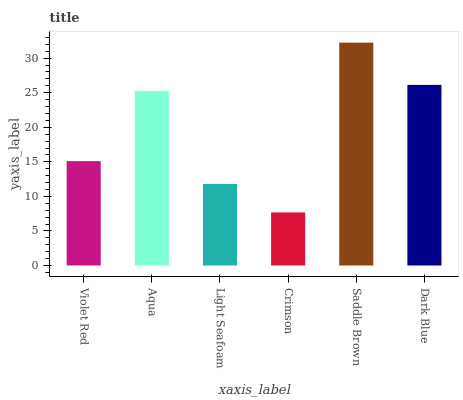Is Crimson the minimum?
Answer yes or no. Yes. Is Saddle Brown the maximum?
Answer yes or no. Yes. Is Aqua the minimum?
Answer yes or no. No. Is Aqua the maximum?
Answer yes or no. No. Is Aqua greater than Violet Red?
Answer yes or no. Yes. Is Violet Red less than Aqua?
Answer yes or no. Yes. Is Violet Red greater than Aqua?
Answer yes or no. No. Is Aqua less than Violet Red?
Answer yes or no. No. Is Aqua the high median?
Answer yes or no. Yes. Is Violet Red the low median?
Answer yes or no. Yes. Is Crimson the high median?
Answer yes or no. No. Is Saddle Brown the low median?
Answer yes or no. No. 